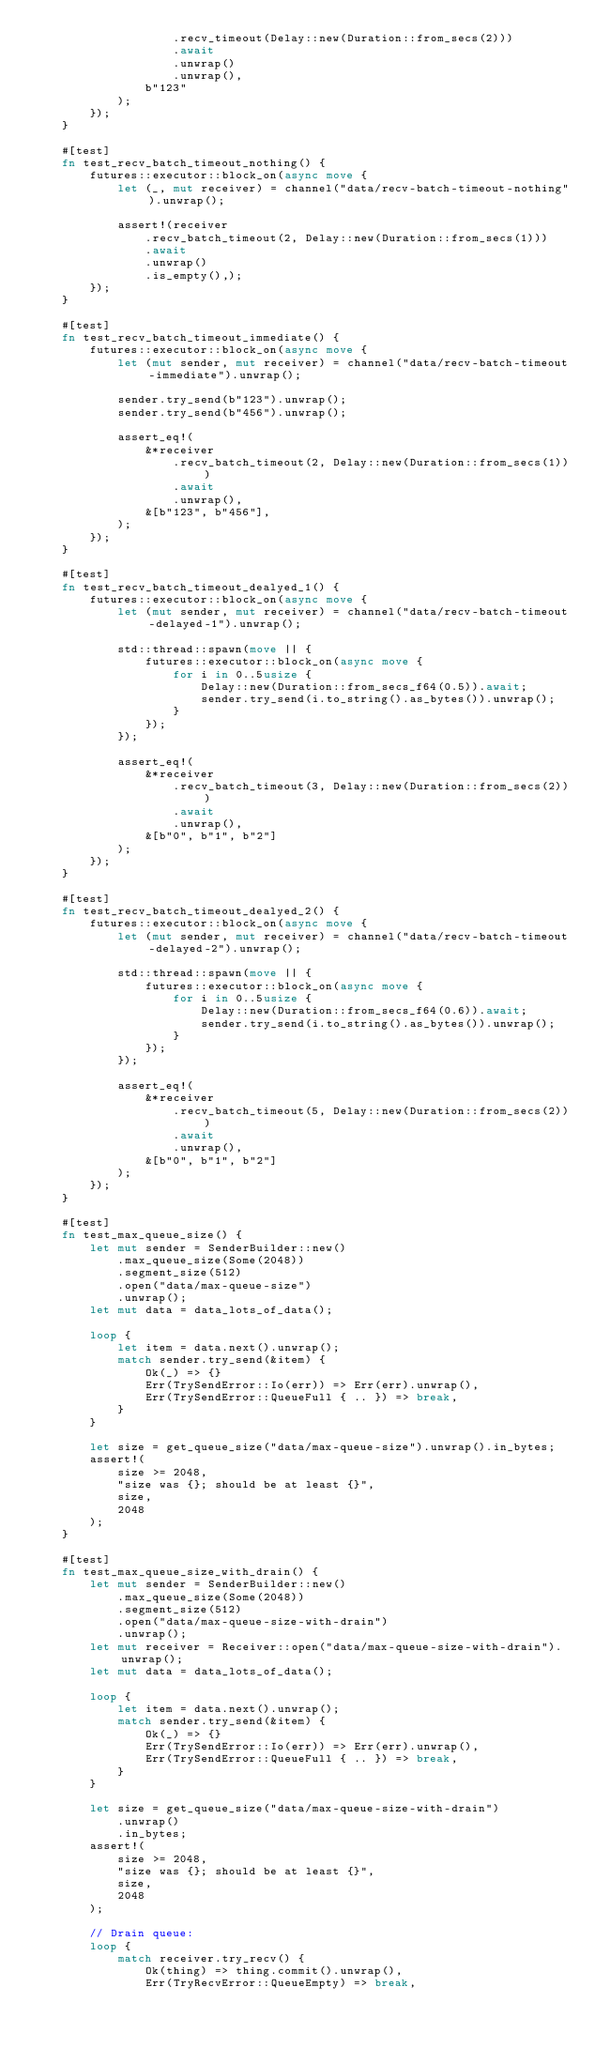<code> <loc_0><loc_0><loc_500><loc_500><_Rust_>                    .recv_timeout(Delay::new(Duration::from_secs(2)))
                    .await
                    .unwrap()
                    .unwrap(),
                b"123"
            );
        });
    }

    #[test]
    fn test_recv_batch_timeout_nothing() {
        futures::executor::block_on(async move {
            let (_, mut receiver) = channel("data/recv-batch-timeout-nothing").unwrap();

            assert!(receiver
                .recv_batch_timeout(2, Delay::new(Duration::from_secs(1)))
                .await
                .unwrap()
                .is_empty(),);
        });
    }

    #[test]
    fn test_recv_batch_timeout_immediate() {
        futures::executor::block_on(async move {
            let (mut sender, mut receiver) = channel("data/recv-batch-timeout-immediate").unwrap();

            sender.try_send(b"123").unwrap();
            sender.try_send(b"456").unwrap();

            assert_eq!(
                &*receiver
                    .recv_batch_timeout(2, Delay::new(Duration::from_secs(1)))
                    .await
                    .unwrap(),
                &[b"123", b"456"],
            );
        });
    }

    #[test]
    fn test_recv_batch_timeout_dealyed_1() {
        futures::executor::block_on(async move {
            let (mut sender, mut receiver) = channel("data/recv-batch-timeout-delayed-1").unwrap();

            std::thread::spawn(move || {
                futures::executor::block_on(async move {
                    for i in 0..5usize {
                        Delay::new(Duration::from_secs_f64(0.5)).await;
                        sender.try_send(i.to_string().as_bytes()).unwrap();
                    }
                });
            });

            assert_eq!(
                &*receiver
                    .recv_batch_timeout(3, Delay::new(Duration::from_secs(2)))
                    .await
                    .unwrap(),
                &[b"0", b"1", b"2"]
            );
        });
    }

    #[test]
    fn test_recv_batch_timeout_dealyed_2() {
        futures::executor::block_on(async move {
            let (mut sender, mut receiver) = channel("data/recv-batch-timeout-delayed-2").unwrap();

            std::thread::spawn(move || {
                futures::executor::block_on(async move {
                    for i in 0..5usize {
                        Delay::new(Duration::from_secs_f64(0.6)).await;
                        sender.try_send(i.to_string().as_bytes()).unwrap();
                    }
                });
            });

            assert_eq!(
                &*receiver
                    .recv_batch_timeout(5, Delay::new(Duration::from_secs(2)))
                    .await
                    .unwrap(),
                &[b"0", b"1", b"2"]
            );
        });
    }

    #[test]
    fn test_max_queue_size() {
        let mut sender = SenderBuilder::new()
            .max_queue_size(Some(2048))
            .segment_size(512)
            .open("data/max-queue-size")
            .unwrap();
        let mut data = data_lots_of_data();

        loop {
            let item = data.next().unwrap();
            match sender.try_send(&item) {
                Ok(_) => {}
                Err(TrySendError::Io(err)) => Err(err).unwrap(),
                Err(TrySendError::QueueFull { .. }) => break,
            }
        }

        let size = get_queue_size("data/max-queue-size").unwrap().in_bytes;
        assert!(
            size >= 2048,
            "size was {}; should be at least {}",
            size,
            2048
        );
    }

    #[test]
    fn test_max_queue_size_with_drain() {
        let mut sender = SenderBuilder::new()
            .max_queue_size(Some(2048))
            .segment_size(512)
            .open("data/max-queue-size-with-drain")
            .unwrap();
        let mut receiver = Receiver::open("data/max-queue-size-with-drain").unwrap();
        let mut data = data_lots_of_data();

        loop {
            let item = data.next().unwrap();
            match sender.try_send(&item) {
                Ok(_) => {}
                Err(TrySendError::Io(err)) => Err(err).unwrap(),
                Err(TrySendError::QueueFull { .. }) => break,
            }
        }

        let size = get_queue_size("data/max-queue-size-with-drain")
            .unwrap()
            .in_bytes;
        assert!(
            size >= 2048,
            "size was {}; should be at least {}",
            size,
            2048
        );

        // Drain queue:
        loop {
            match receiver.try_recv() {
                Ok(thing) => thing.commit().unwrap(),
                Err(TryRecvError::QueueEmpty) => break,</code> 